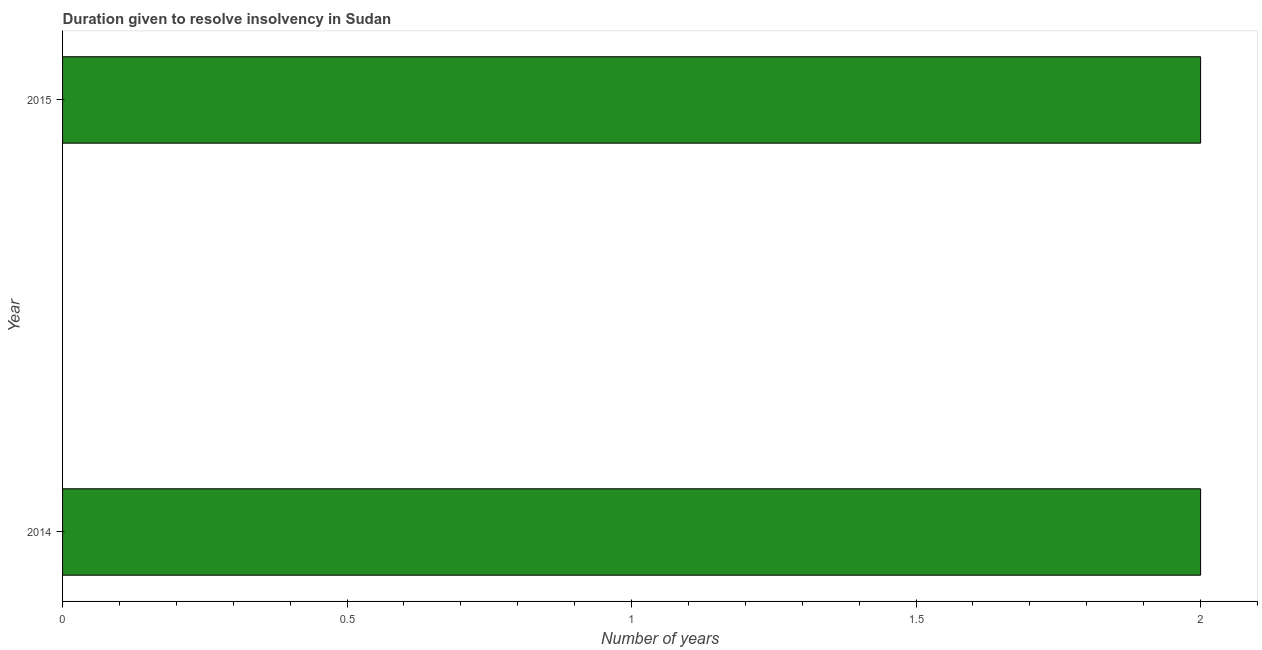Does the graph contain any zero values?
Your response must be concise. No. What is the title of the graph?
Provide a short and direct response. Duration given to resolve insolvency in Sudan. What is the label or title of the X-axis?
Your answer should be compact. Number of years. What is the label or title of the Y-axis?
Offer a very short reply. Year. Across all years, what is the maximum number of years to resolve insolvency?
Provide a succinct answer. 2. Across all years, what is the minimum number of years to resolve insolvency?
Ensure brevity in your answer.  2. What is the average number of years to resolve insolvency per year?
Make the answer very short. 2. In how many years, is the number of years to resolve insolvency greater than 0.8 ?
Offer a terse response. 2. What is the ratio of the number of years to resolve insolvency in 2014 to that in 2015?
Make the answer very short. 1. Is the number of years to resolve insolvency in 2014 less than that in 2015?
Your response must be concise. No. How many bars are there?
Make the answer very short. 2. What is the Number of years in 2014?
Make the answer very short. 2. What is the ratio of the Number of years in 2014 to that in 2015?
Give a very brief answer. 1. 